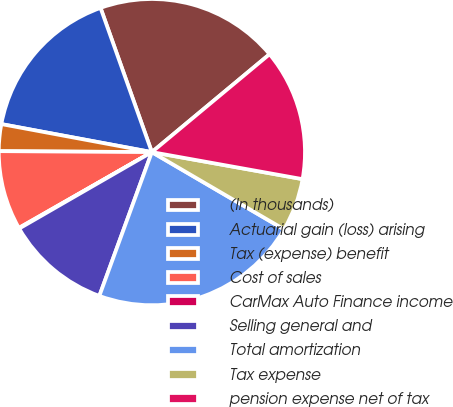Convert chart. <chart><loc_0><loc_0><loc_500><loc_500><pie_chart><fcel>(In thousands)<fcel>Actuarial gain (loss) arising<fcel>Tax (expense) benefit<fcel>Cost of sales<fcel>CarMax Auto Finance income<fcel>Selling general and<fcel>Total amortization<fcel>Tax expense<fcel>pension expense net of tax<nl><fcel>19.4%<fcel>16.63%<fcel>2.83%<fcel>8.35%<fcel>0.07%<fcel>11.11%<fcel>22.16%<fcel>5.59%<fcel>13.87%<nl></chart> 